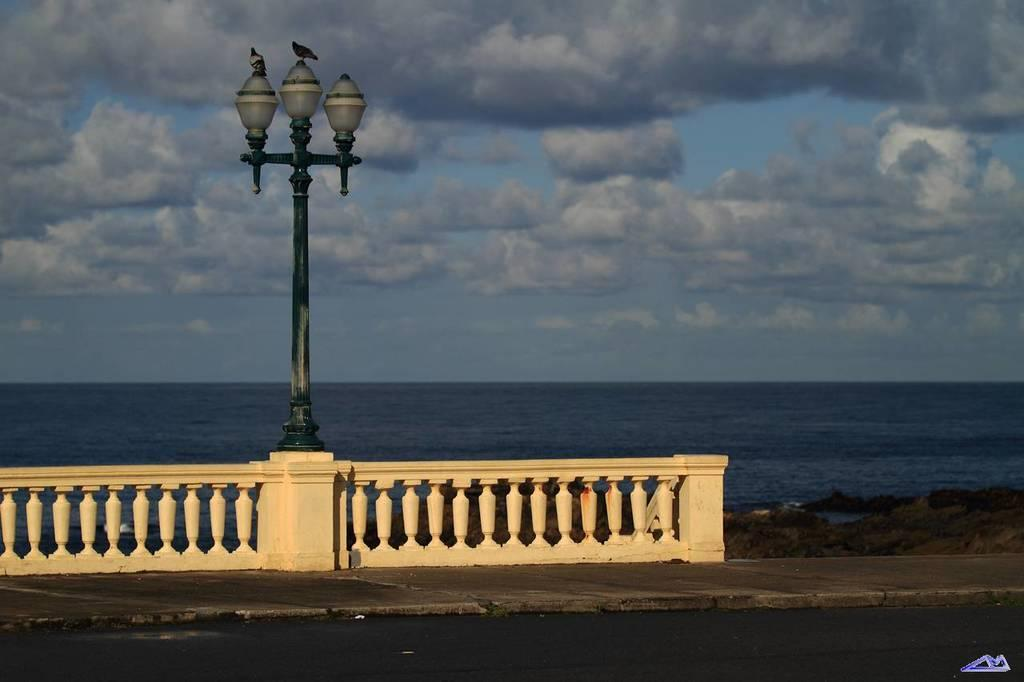What type of natural body of water is visible in the image? There is a sea in the image. What is located in front of the sea? There is a fence and street light poles in front of the sea. What can be seen above the sea in the image? The sky is visible in the image. What is the condition of the sky in the image? The sky is cloudy in the image. How many strings are attached to the clover in the image? There is no clover or string present in the image. 